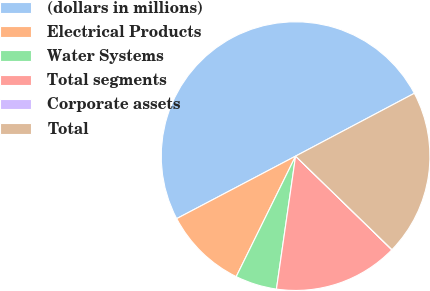Convert chart to OTSL. <chart><loc_0><loc_0><loc_500><loc_500><pie_chart><fcel>(dollars in millions)<fcel>Electrical Products<fcel>Water Systems<fcel>Total segments<fcel>Corporate assets<fcel>Total<nl><fcel>49.96%<fcel>10.01%<fcel>5.01%<fcel>15.0%<fcel>0.02%<fcel>20.0%<nl></chart> 